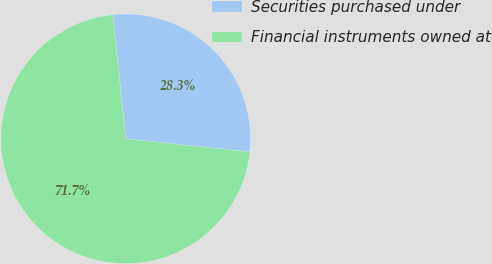Convert chart to OTSL. <chart><loc_0><loc_0><loc_500><loc_500><pie_chart><fcel>Securities purchased under<fcel>Financial instruments owned at<nl><fcel>28.32%<fcel>71.68%<nl></chart> 